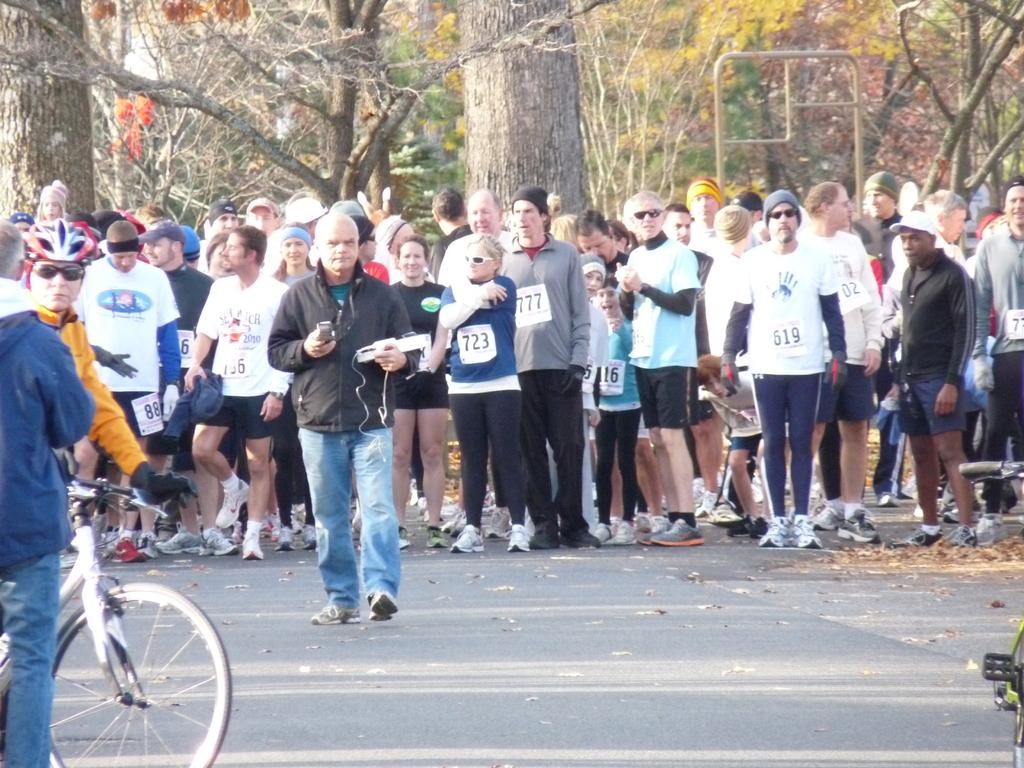What are the people in the image doing? There is a group of people standing on the road. Can you describe the man in the image? The man is wearing a yellow jacket and sitting on a cycle. Where is the man located in the image? The man is on the left side of the image. What is the man doing in the image? The man is sitting on a cycle. What can be seen in the background of the image? There are trees in the background of the image. How many eggs are being carried by the people in the image? There are no eggs visible in the image; the people are standing on the road and the man is sitting on a cycle. In which direction are the people in the image facing? The provided facts do not specify the direction the people are facing, so it cannot be determined from the image. 